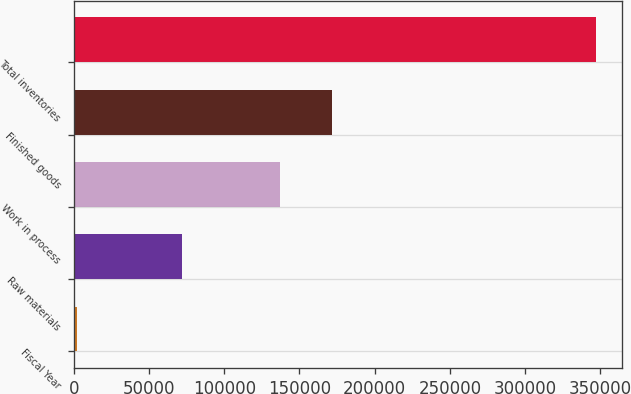<chart> <loc_0><loc_0><loc_500><loc_500><bar_chart><fcel>Fiscal Year<fcel>Raw materials<fcel>Work in process<fcel>Finished goods<fcel>Total inventories<nl><fcel>2015<fcel>71863<fcel>137306<fcel>171794<fcel>346900<nl></chart> 